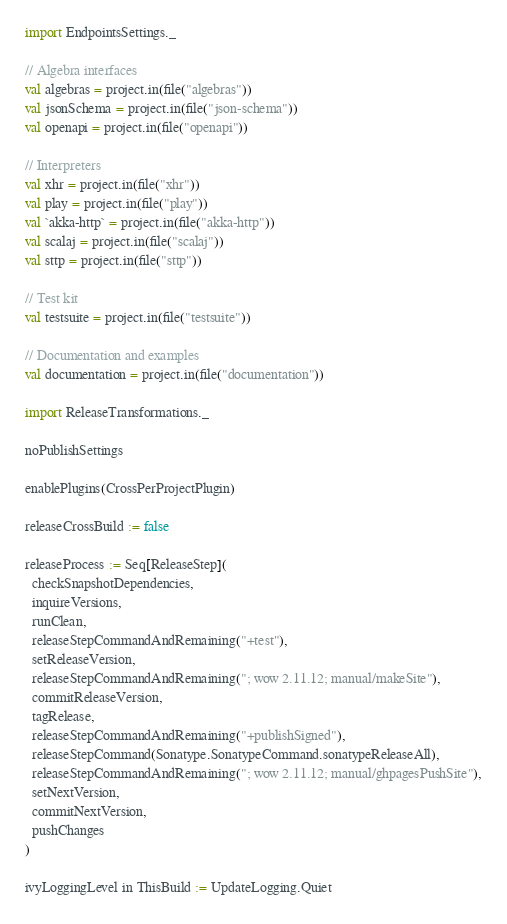Convert code to text. <code><loc_0><loc_0><loc_500><loc_500><_Scala_>import EndpointsSettings._

// Algebra interfaces
val algebras = project.in(file("algebras"))
val jsonSchema = project.in(file("json-schema"))
val openapi = project.in(file("openapi"))

// Interpreters
val xhr = project.in(file("xhr"))
val play = project.in(file("play"))
val `akka-http` = project.in(file("akka-http"))
val scalaj = project.in(file("scalaj"))
val sttp = project.in(file("sttp"))

// Test kit
val testsuite = project.in(file("testsuite"))

// Documentation and examples
val documentation = project.in(file("documentation"))

import ReleaseTransformations._

noPublishSettings

enablePlugins(CrossPerProjectPlugin)

releaseCrossBuild := false

releaseProcess := Seq[ReleaseStep](
  checkSnapshotDependencies,
  inquireVersions,
  runClean,
  releaseStepCommandAndRemaining("+test"),
  setReleaseVersion,
  releaseStepCommandAndRemaining("; wow 2.11.12; manual/makeSite"),
  commitReleaseVersion,
  tagRelease,
  releaseStepCommandAndRemaining("+publishSigned"),
  releaseStepCommand(Sonatype.SonatypeCommand.sonatypeReleaseAll),
  releaseStepCommandAndRemaining("; wow 2.11.12; manual/ghpagesPushSite"),
  setNextVersion,
  commitNextVersion,
  pushChanges
)

ivyLoggingLevel in ThisBuild := UpdateLogging.Quiet
</code> 